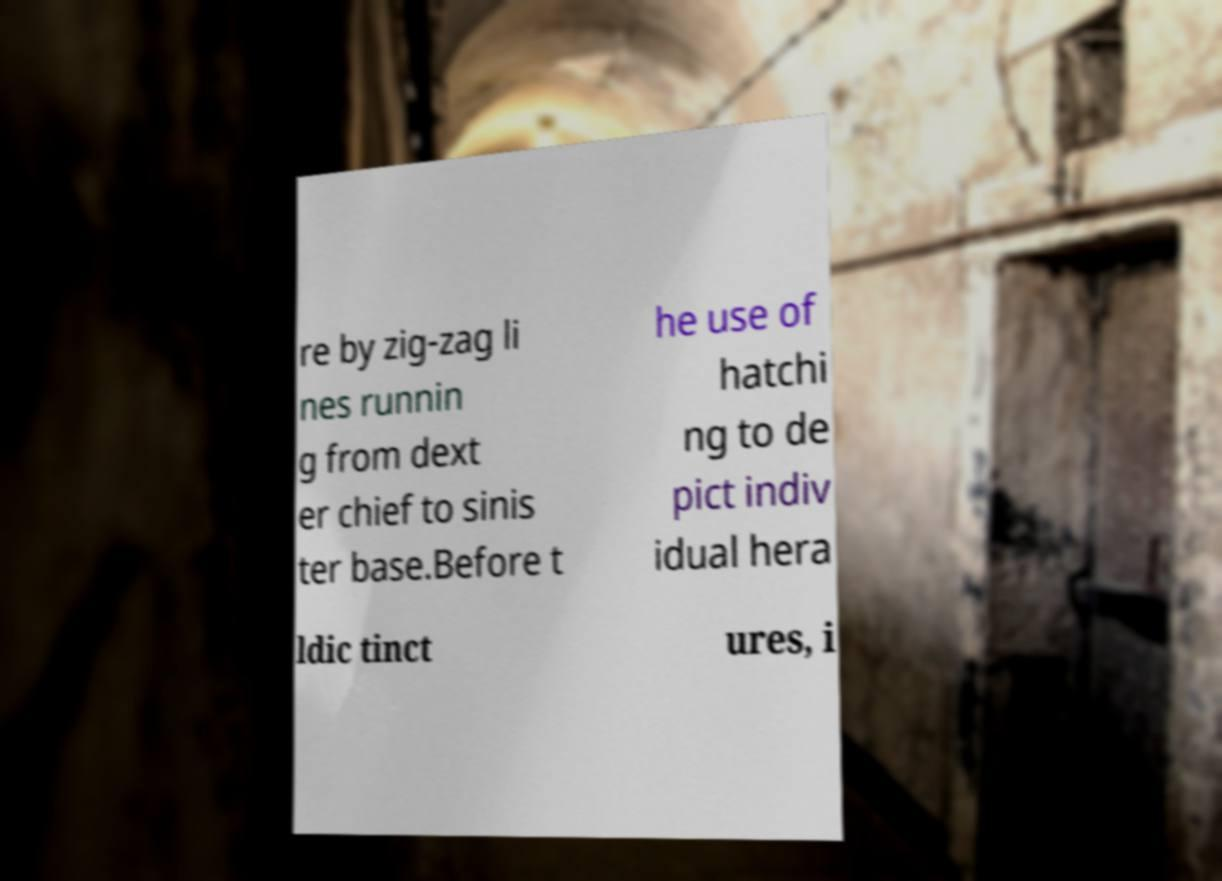Can you accurately transcribe the text from the provided image for me? re by zig-zag li nes runnin g from dext er chief to sinis ter base.Before t he use of hatchi ng to de pict indiv idual hera ldic tinct ures, i 